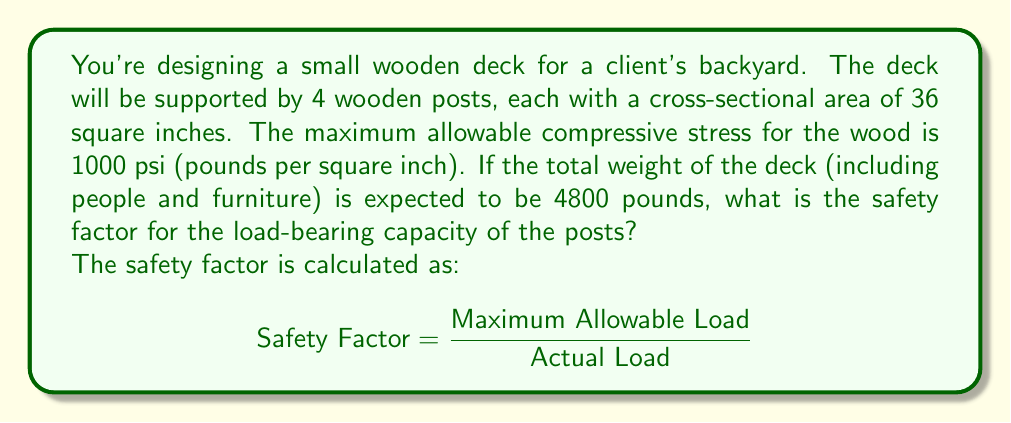Help me with this question. Let's approach this step-by-step:

1) First, we need to calculate the maximum allowable load for all 4 posts combined.

2) The maximum allowable load for each post is the product of its cross-sectional area and the maximum allowable compressive stress:

   $$ \text{Max Load per Post} = \text{Area} \times \text{Max Stress} $$
   $$ = 36 \text{ in}^2 \times 1000 \text{ psi} = 36,000 \text{ lbs} $$

3) For all 4 posts:

   $$ \text{Total Max Load} = 4 \times 36,000 \text{ lbs} = 144,000 \text{ lbs} $$

4) Now we can calculate the safety factor:

   $$ \text{Safety Factor} = \frac{\text{Maximum Allowable Load}}{\text{Actual Load}} $$
   $$ = \frac{144,000 \text{ lbs}}{4,800 \text{ lbs}} = 30 $$

This means the posts can theoretically support 30 times the expected load, providing a very high margin of safety.
Answer: The safety factor is 30. 